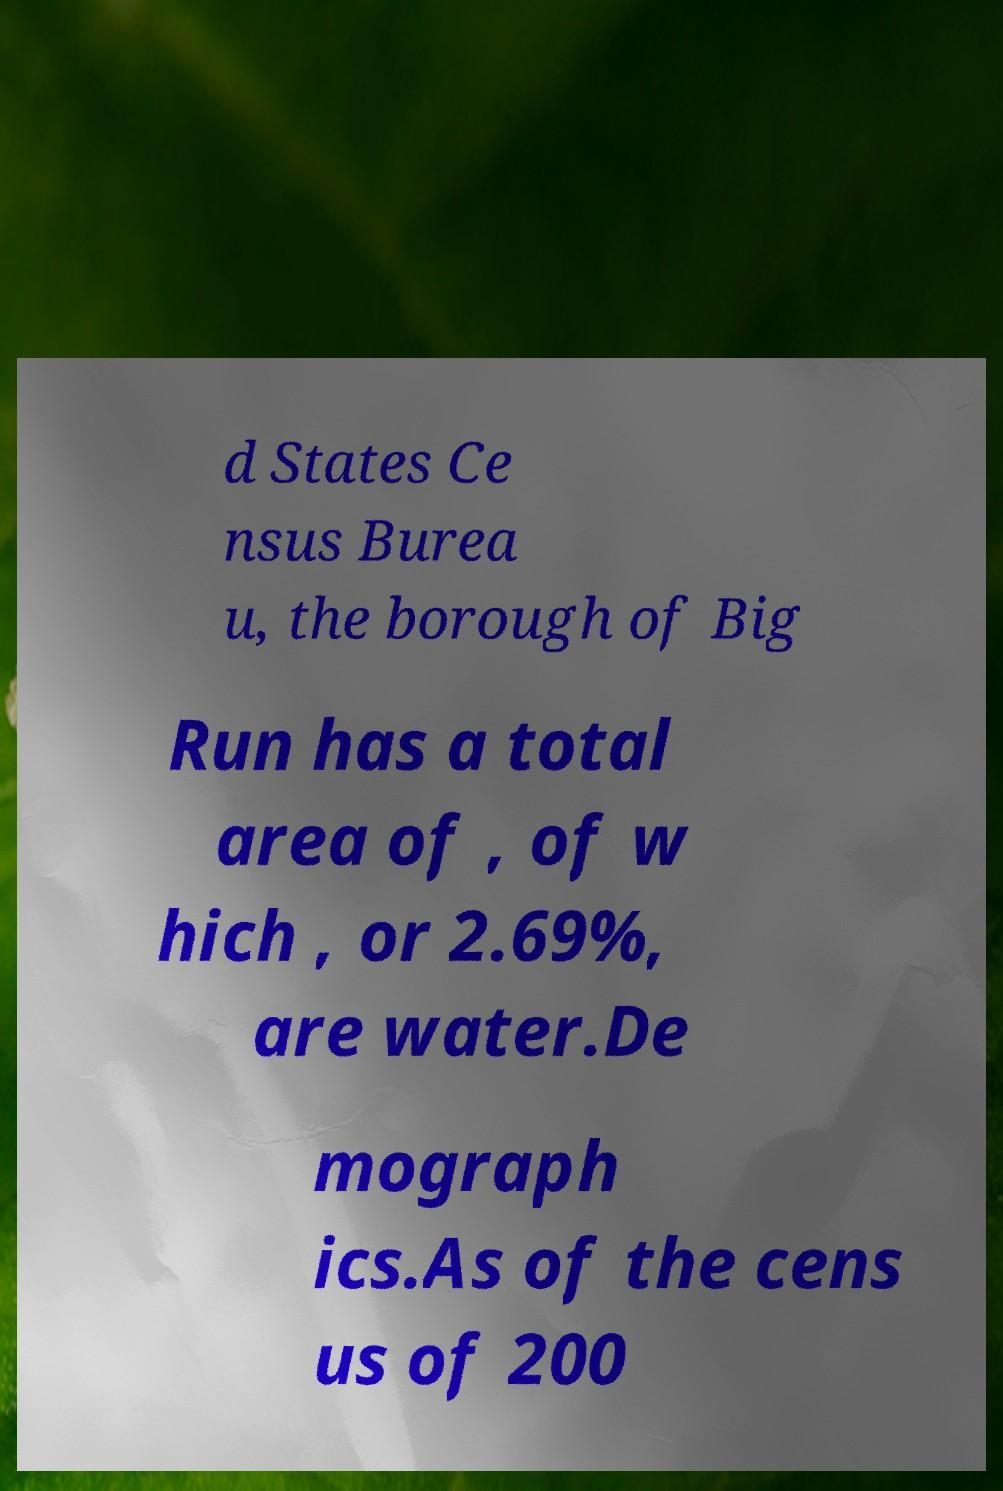Please read and relay the text visible in this image. What does it say? d States Ce nsus Burea u, the borough of Big Run has a total area of , of w hich , or 2.69%, are water.De mograph ics.As of the cens us of 200 